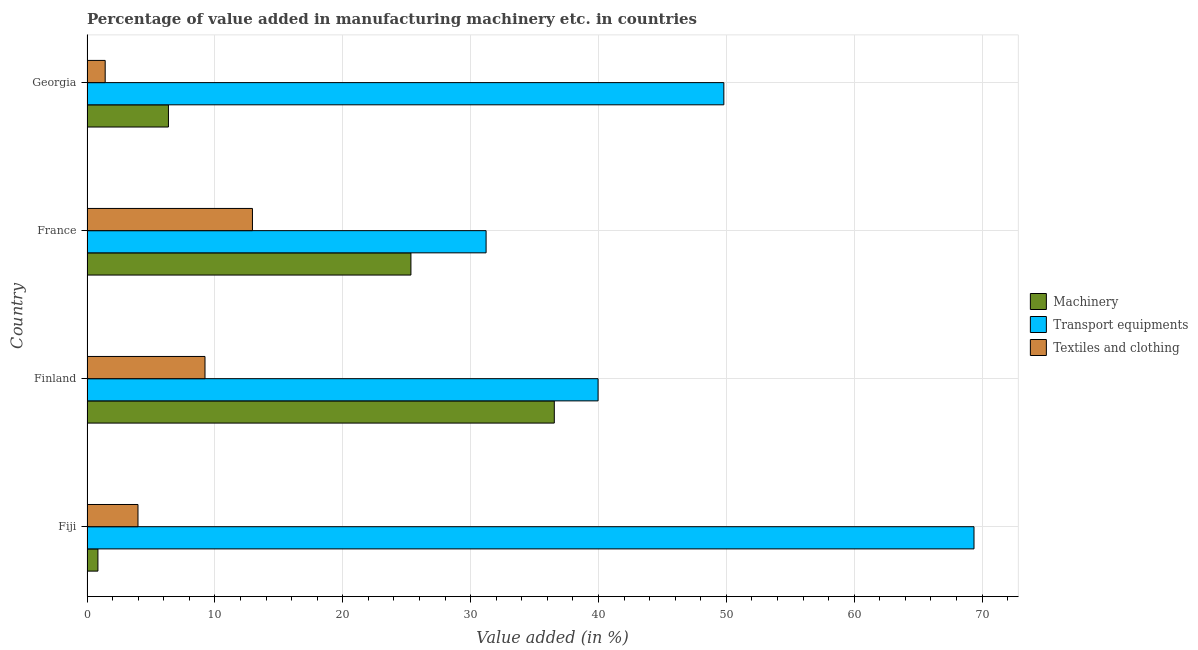How many different coloured bars are there?
Provide a short and direct response. 3. Are the number of bars per tick equal to the number of legend labels?
Make the answer very short. Yes. Are the number of bars on each tick of the Y-axis equal?
Ensure brevity in your answer.  Yes. What is the label of the 3rd group of bars from the top?
Offer a very short reply. Finland. What is the value added in manufacturing transport equipments in Finland?
Offer a very short reply. 39.97. Across all countries, what is the maximum value added in manufacturing transport equipments?
Give a very brief answer. 69.37. Across all countries, what is the minimum value added in manufacturing machinery?
Your answer should be compact. 0.85. In which country was the value added in manufacturing transport equipments maximum?
Provide a succinct answer. Fiji. In which country was the value added in manufacturing machinery minimum?
Provide a succinct answer. Fiji. What is the total value added in manufacturing machinery in the graph?
Your answer should be very brief. 69.1. What is the difference between the value added in manufacturing machinery in Fiji and that in Finland?
Your answer should be compact. -35.69. What is the difference between the value added in manufacturing textile and clothing in Finland and the value added in manufacturing transport equipments in France?
Make the answer very short. -21.98. What is the average value added in manufacturing textile and clothing per country?
Your answer should be compact. 6.89. What is the difference between the value added in manufacturing textile and clothing and value added in manufacturing transport equipments in Fiji?
Give a very brief answer. -65.38. What is the ratio of the value added in manufacturing textile and clothing in France to that in Georgia?
Your answer should be very brief. 9.1. Is the value added in manufacturing transport equipments in France less than that in Georgia?
Give a very brief answer. Yes. What is the difference between the highest and the second highest value added in manufacturing transport equipments?
Ensure brevity in your answer.  19.56. What is the difference between the highest and the lowest value added in manufacturing textile and clothing?
Your response must be concise. 11.52. Is the sum of the value added in manufacturing textile and clothing in Fiji and Finland greater than the maximum value added in manufacturing machinery across all countries?
Ensure brevity in your answer.  No. What does the 1st bar from the top in Finland represents?
Give a very brief answer. Textiles and clothing. What does the 3rd bar from the bottom in Georgia represents?
Offer a terse response. Textiles and clothing. Are all the bars in the graph horizontal?
Offer a very short reply. Yes. What is the difference between two consecutive major ticks on the X-axis?
Ensure brevity in your answer.  10. Does the graph contain any zero values?
Ensure brevity in your answer.  No. How many legend labels are there?
Ensure brevity in your answer.  3. What is the title of the graph?
Your response must be concise. Percentage of value added in manufacturing machinery etc. in countries. What is the label or title of the X-axis?
Give a very brief answer. Value added (in %). What is the label or title of the Y-axis?
Make the answer very short. Country. What is the Value added (in %) of Machinery in Fiji?
Your response must be concise. 0.85. What is the Value added (in %) of Transport equipments in Fiji?
Offer a very short reply. 69.37. What is the Value added (in %) in Textiles and clothing in Fiji?
Provide a short and direct response. 3.99. What is the Value added (in %) in Machinery in Finland?
Keep it short and to the point. 36.54. What is the Value added (in %) in Transport equipments in Finland?
Your answer should be compact. 39.97. What is the Value added (in %) in Textiles and clothing in Finland?
Provide a succinct answer. 9.23. What is the Value added (in %) of Machinery in France?
Make the answer very short. 25.33. What is the Value added (in %) of Transport equipments in France?
Your answer should be compact. 31.21. What is the Value added (in %) in Textiles and clothing in France?
Provide a short and direct response. 12.94. What is the Value added (in %) in Machinery in Georgia?
Give a very brief answer. 6.37. What is the Value added (in %) in Transport equipments in Georgia?
Offer a terse response. 49.8. What is the Value added (in %) of Textiles and clothing in Georgia?
Give a very brief answer. 1.42. Across all countries, what is the maximum Value added (in %) of Machinery?
Your answer should be compact. 36.54. Across all countries, what is the maximum Value added (in %) of Transport equipments?
Provide a short and direct response. 69.37. Across all countries, what is the maximum Value added (in %) of Textiles and clothing?
Your answer should be very brief. 12.94. Across all countries, what is the minimum Value added (in %) in Machinery?
Your answer should be compact. 0.85. Across all countries, what is the minimum Value added (in %) of Transport equipments?
Your response must be concise. 31.21. Across all countries, what is the minimum Value added (in %) of Textiles and clothing?
Give a very brief answer. 1.42. What is the total Value added (in %) in Machinery in the graph?
Give a very brief answer. 69.1. What is the total Value added (in %) of Transport equipments in the graph?
Make the answer very short. 190.35. What is the total Value added (in %) of Textiles and clothing in the graph?
Your answer should be very brief. 27.58. What is the difference between the Value added (in %) in Machinery in Fiji and that in Finland?
Your response must be concise. -35.69. What is the difference between the Value added (in %) of Transport equipments in Fiji and that in Finland?
Your answer should be compact. 29.4. What is the difference between the Value added (in %) of Textiles and clothing in Fiji and that in Finland?
Your answer should be very brief. -5.24. What is the difference between the Value added (in %) in Machinery in Fiji and that in France?
Keep it short and to the point. -24.48. What is the difference between the Value added (in %) in Transport equipments in Fiji and that in France?
Your response must be concise. 38.16. What is the difference between the Value added (in %) of Textiles and clothing in Fiji and that in France?
Give a very brief answer. -8.95. What is the difference between the Value added (in %) in Machinery in Fiji and that in Georgia?
Make the answer very short. -5.51. What is the difference between the Value added (in %) in Transport equipments in Fiji and that in Georgia?
Make the answer very short. 19.56. What is the difference between the Value added (in %) of Textiles and clothing in Fiji and that in Georgia?
Give a very brief answer. 2.56. What is the difference between the Value added (in %) of Machinery in Finland and that in France?
Offer a terse response. 11.21. What is the difference between the Value added (in %) in Transport equipments in Finland and that in France?
Provide a succinct answer. 8.76. What is the difference between the Value added (in %) of Textiles and clothing in Finland and that in France?
Offer a very short reply. -3.71. What is the difference between the Value added (in %) of Machinery in Finland and that in Georgia?
Provide a short and direct response. 30.18. What is the difference between the Value added (in %) in Transport equipments in Finland and that in Georgia?
Offer a terse response. -9.84. What is the difference between the Value added (in %) in Textiles and clothing in Finland and that in Georgia?
Keep it short and to the point. 7.81. What is the difference between the Value added (in %) of Machinery in France and that in Georgia?
Keep it short and to the point. 18.96. What is the difference between the Value added (in %) in Transport equipments in France and that in Georgia?
Keep it short and to the point. -18.59. What is the difference between the Value added (in %) of Textiles and clothing in France and that in Georgia?
Your response must be concise. 11.52. What is the difference between the Value added (in %) in Machinery in Fiji and the Value added (in %) in Transport equipments in Finland?
Provide a short and direct response. -39.11. What is the difference between the Value added (in %) in Machinery in Fiji and the Value added (in %) in Textiles and clothing in Finland?
Keep it short and to the point. -8.37. What is the difference between the Value added (in %) of Transport equipments in Fiji and the Value added (in %) of Textiles and clothing in Finland?
Provide a succinct answer. 60.14. What is the difference between the Value added (in %) in Machinery in Fiji and the Value added (in %) in Transport equipments in France?
Offer a terse response. -30.36. What is the difference between the Value added (in %) in Machinery in Fiji and the Value added (in %) in Textiles and clothing in France?
Your response must be concise. -12.09. What is the difference between the Value added (in %) in Transport equipments in Fiji and the Value added (in %) in Textiles and clothing in France?
Provide a short and direct response. 56.43. What is the difference between the Value added (in %) in Machinery in Fiji and the Value added (in %) in Transport equipments in Georgia?
Ensure brevity in your answer.  -48.95. What is the difference between the Value added (in %) of Machinery in Fiji and the Value added (in %) of Textiles and clothing in Georgia?
Your response must be concise. -0.57. What is the difference between the Value added (in %) of Transport equipments in Fiji and the Value added (in %) of Textiles and clothing in Georgia?
Offer a terse response. 67.94. What is the difference between the Value added (in %) of Machinery in Finland and the Value added (in %) of Transport equipments in France?
Your answer should be very brief. 5.33. What is the difference between the Value added (in %) of Machinery in Finland and the Value added (in %) of Textiles and clothing in France?
Offer a terse response. 23.6. What is the difference between the Value added (in %) in Transport equipments in Finland and the Value added (in %) in Textiles and clothing in France?
Provide a succinct answer. 27.03. What is the difference between the Value added (in %) in Machinery in Finland and the Value added (in %) in Transport equipments in Georgia?
Make the answer very short. -13.26. What is the difference between the Value added (in %) in Machinery in Finland and the Value added (in %) in Textiles and clothing in Georgia?
Provide a succinct answer. 35.12. What is the difference between the Value added (in %) of Transport equipments in Finland and the Value added (in %) of Textiles and clothing in Georgia?
Provide a short and direct response. 38.55. What is the difference between the Value added (in %) in Machinery in France and the Value added (in %) in Transport equipments in Georgia?
Your response must be concise. -24.47. What is the difference between the Value added (in %) of Machinery in France and the Value added (in %) of Textiles and clothing in Georgia?
Offer a terse response. 23.91. What is the difference between the Value added (in %) of Transport equipments in France and the Value added (in %) of Textiles and clothing in Georgia?
Your answer should be very brief. 29.79. What is the average Value added (in %) of Machinery per country?
Provide a succinct answer. 17.27. What is the average Value added (in %) of Transport equipments per country?
Give a very brief answer. 47.59. What is the average Value added (in %) of Textiles and clothing per country?
Give a very brief answer. 6.89. What is the difference between the Value added (in %) of Machinery and Value added (in %) of Transport equipments in Fiji?
Your answer should be compact. -68.51. What is the difference between the Value added (in %) of Machinery and Value added (in %) of Textiles and clothing in Fiji?
Your response must be concise. -3.13. What is the difference between the Value added (in %) in Transport equipments and Value added (in %) in Textiles and clothing in Fiji?
Make the answer very short. 65.38. What is the difference between the Value added (in %) of Machinery and Value added (in %) of Transport equipments in Finland?
Provide a short and direct response. -3.42. What is the difference between the Value added (in %) of Machinery and Value added (in %) of Textiles and clothing in Finland?
Make the answer very short. 27.32. What is the difference between the Value added (in %) of Transport equipments and Value added (in %) of Textiles and clothing in Finland?
Provide a short and direct response. 30.74. What is the difference between the Value added (in %) in Machinery and Value added (in %) in Transport equipments in France?
Keep it short and to the point. -5.88. What is the difference between the Value added (in %) in Machinery and Value added (in %) in Textiles and clothing in France?
Your answer should be very brief. 12.39. What is the difference between the Value added (in %) in Transport equipments and Value added (in %) in Textiles and clothing in France?
Ensure brevity in your answer.  18.27. What is the difference between the Value added (in %) in Machinery and Value added (in %) in Transport equipments in Georgia?
Offer a very short reply. -43.44. What is the difference between the Value added (in %) in Machinery and Value added (in %) in Textiles and clothing in Georgia?
Offer a terse response. 4.95. What is the difference between the Value added (in %) in Transport equipments and Value added (in %) in Textiles and clothing in Georgia?
Provide a short and direct response. 48.38. What is the ratio of the Value added (in %) in Machinery in Fiji to that in Finland?
Your answer should be very brief. 0.02. What is the ratio of the Value added (in %) of Transport equipments in Fiji to that in Finland?
Offer a terse response. 1.74. What is the ratio of the Value added (in %) in Textiles and clothing in Fiji to that in Finland?
Give a very brief answer. 0.43. What is the ratio of the Value added (in %) in Machinery in Fiji to that in France?
Provide a short and direct response. 0.03. What is the ratio of the Value added (in %) in Transport equipments in Fiji to that in France?
Keep it short and to the point. 2.22. What is the ratio of the Value added (in %) in Textiles and clothing in Fiji to that in France?
Your answer should be very brief. 0.31. What is the ratio of the Value added (in %) in Machinery in Fiji to that in Georgia?
Provide a short and direct response. 0.13. What is the ratio of the Value added (in %) of Transport equipments in Fiji to that in Georgia?
Provide a short and direct response. 1.39. What is the ratio of the Value added (in %) of Textiles and clothing in Fiji to that in Georgia?
Provide a succinct answer. 2.8. What is the ratio of the Value added (in %) of Machinery in Finland to that in France?
Ensure brevity in your answer.  1.44. What is the ratio of the Value added (in %) of Transport equipments in Finland to that in France?
Make the answer very short. 1.28. What is the ratio of the Value added (in %) in Textiles and clothing in Finland to that in France?
Your response must be concise. 0.71. What is the ratio of the Value added (in %) in Machinery in Finland to that in Georgia?
Keep it short and to the point. 5.74. What is the ratio of the Value added (in %) in Transport equipments in Finland to that in Georgia?
Ensure brevity in your answer.  0.8. What is the ratio of the Value added (in %) of Textiles and clothing in Finland to that in Georgia?
Make the answer very short. 6.49. What is the ratio of the Value added (in %) in Machinery in France to that in Georgia?
Your response must be concise. 3.98. What is the ratio of the Value added (in %) of Transport equipments in France to that in Georgia?
Offer a very short reply. 0.63. What is the ratio of the Value added (in %) of Textiles and clothing in France to that in Georgia?
Make the answer very short. 9.1. What is the difference between the highest and the second highest Value added (in %) in Machinery?
Offer a very short reply. 11.21. What is the difference between the highest and the second highest Value added (in %) of Transport equipments?
Your answer should be compact. 19.56. What is the difference between the highest and the second highest Value added (in %) in Textiles and clothing?
Give a very brief answer. 3.71. What is the difference between the highest and the lowest Value added (in %) in Machinery?
Offer a terse response. 35.69. What is the difference between the highest and the lowest Value added (in %) of Transport equipments?
Offer a terse response. 38.16. What is the difference between the highest and the lowest Value added (in %) of Textiles and clothing?
Provide a short and direct response. 11.52. 